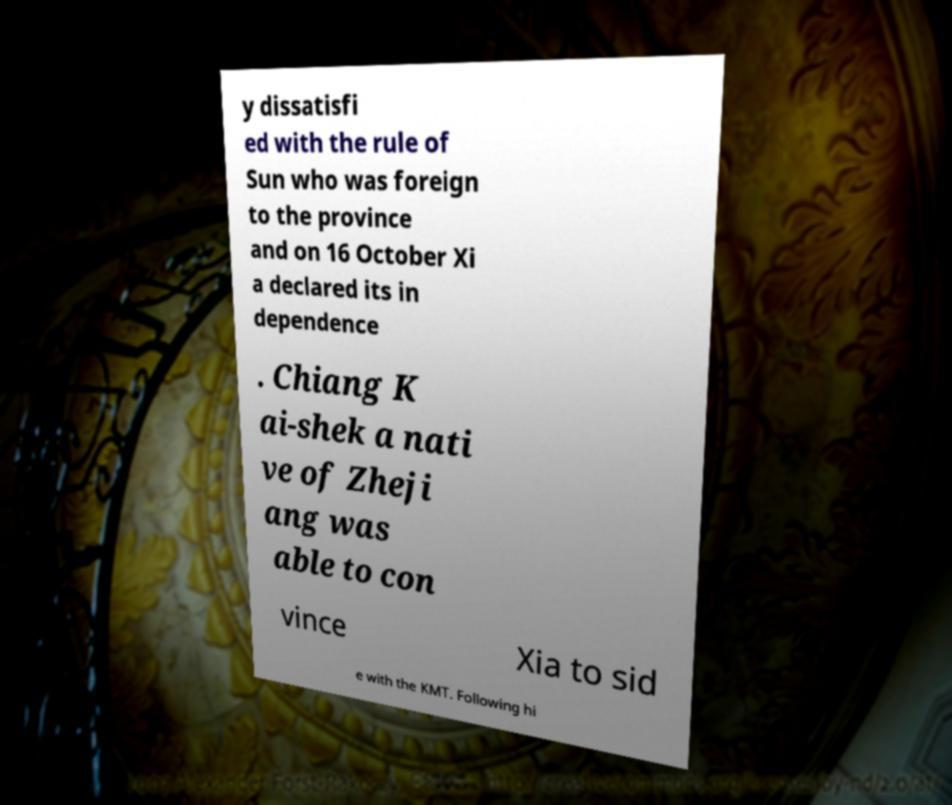Please identify and transcribe the text found in this image. y dissatisfi ed with the rule of Sun who was foreign to the province and on 16 October Xi a declared its in dependence . Chiang K ai-shek a nati ve of Zheji ang was able to con vince Xia to sid e with the KMT. Following hi 